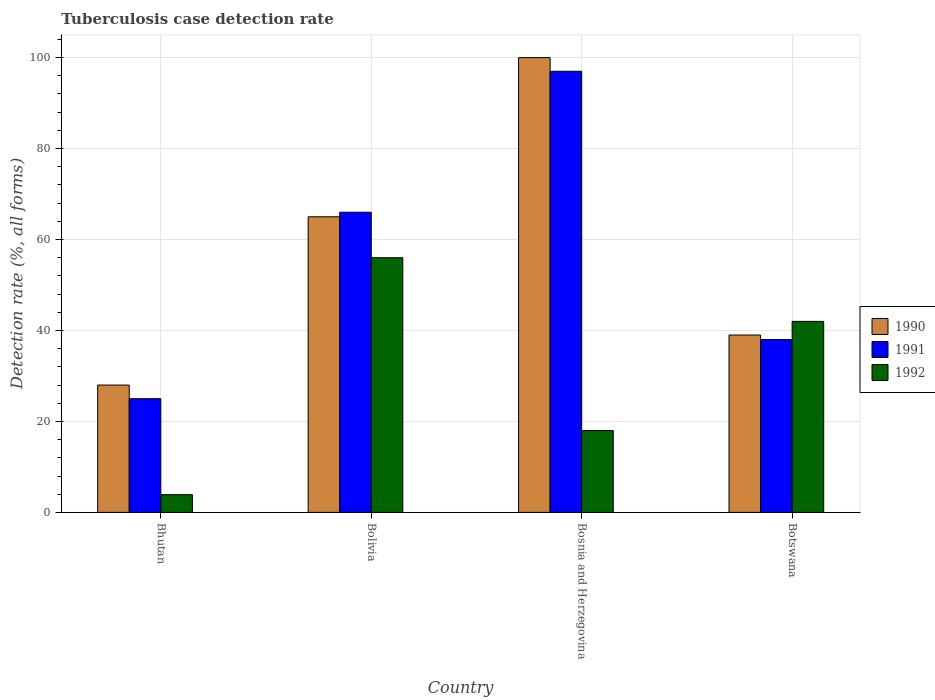How many groups of bars are there?
Give a very brief answer. 4. What is the label of the 3rd group of bars from the left?
Your answer should be compact. Bosnia and Herzegovina. What is the tuberculosis case detection rate in in 1992 in Bhutan?
Offer a very short reply. 3.9. Across all countries, what is the maximum tuberculosis case detection rate in in 1991?
Offer a terse response. 97. Across all countries, what is the minimum tuberculosis case detection rate in in 1990?
Your answer should be compact. 28. In which country was the tuberculosis case detection rate in in 1991 maximum?
Your answer should be very brief. Bosnia and Herzegovina. In which country was the tuberculosis case detection rate in in 1992 minimum?
Offer a terse response. Bhutan. What is the total tuberculosis case detection rate in in 1990 in the graph?
Make the answer very short. 232. What is the difference between the tuberculosis case detection rate in in 1992 in Bhutan and that in Bolivia?
Keep it short and to the point. -52.1. What is the average tuberculosis case detection rate in in 1991 per country?
Give a very brief answer. 56.5. In how many countries, is the tuberculosis case detection rate in in 1991 greater than 48 %?
Ensure brevity in your answer.  2. What is the ratio of the tuberculosis case detection rate in in 1992 in Bhutan to that in Bosnia and Herzegovina?
Give a very brief answer. 0.22. Is the difference between the tuberculosis case detection rate in in 1991 in Bolivia and Bosnia and Herzegovina greater than the difference between the tuberculosis case detection rate in in 1990 in Bolivia and Bosnia and Herzegovina?
Your answer should be very brief. Yes. What is the difference between the highest and the second highest tuberculosis case detection rate in in 1990?
Ensure brevity in your answer.  -35. What is the difference between the highest and the lowest tuberculosis case detection rate in in 1991?
Your response must be concise. 72. In how many countries, is the tuberculosis case detection rate in in 1992 greater than the average tuberculosis case detection rate in in 1992 taken over all countries?
Your answer should be very brief. 2. Is the sum of the tuberculosis case detection rate in in 1990 in Bolivia and Botswana greater than the maximum tuberculosis case detection rate in in 1991 across all countries?
Keep it short and to the point. Yes. What does the 2nd bar from the left in Botswana represents?
Your answer should be very brief. 1991. What does the 3rd bar from the right in Bhutan represents?
Provide a short and direct response. 1990. Is it the case that in every country, the sum of the tuberculosis case detection rate in in 1992 and tuberculosis case detection rate in in 1990 is greater than the tuberculosis case detection rate in in 1991?
Make the answer very short. Yes. Are all the bars in the graph horizontal?
Ensure brevity in your answer.  No. Where does the legend appear in the graph?
Provide a succinct answer. Center right. How are the legend labels stacked?
Your answer should be very brief. Vertical. What is the title of the graph?
Provide a succinct answer. Tuberculosis case detection rate. What is the label or title of the Y-axis?
Make the answer very short. Detection rate (%, all forms). What is the Detection rate (%, all forms) in 1990 in Bhutan?
Provide a succinct answer. 28. What is the Detection rate (%, all forms) in 1991 in Bhutan?
Offer a very short reply. 25. What is the Detection rate (%, all forms) in 1990 in Bolivia?
Your response must be concise. 65. What is the Detection rate (%, all forms) in 1991 in Bolivia?
Provide a short and direct response. 66. What is the Detection rate (%, all forms) of 1992 in Bolivia?
Provide a succinct answer. 56. What is the Detection rate (%, all forms) of 1991 in Bosnia and Herzegovina?
Keep it short and to the point. 97. What is the Detection rate (%, all forms) in 1992 in Bosnia and Herzegovina?
Ensure brevity in your answer.  18. Across all countries, what is the maximum Detection rate (%, all forms) in 1991?
Ensure brevity in your answer.  97. Across all countries, what is the maximum Detection rate (%, all forms) in 1992?
Give a very brief answer. 56. Across all countries, what is the minimum Detection rate (%, all forms) in 1991?
Make the answer very short. 25. Across all countries, what is the minimum Detection rate (%, all forms) in 1992?
Offer a terse response. 3.9. What is the total Detection rate (%, all forms) in 1990 in the graph?
Provide a short and direct response. 232. What is the total Detection rate (%, all forms) of 1991 in the graph?
Provide a succinct answer. 226. What is the total Detection rate (%, all forms) of 1992 in the graph?
Offer a very short reply. 119.9. What is the difference between the Detection rate (%, all forms) of 1990 in Bhutan and that in Bolivia?
Your answer should be compact. -37. What is the difference between the Detection rate (%, all forms) of 1991 in Bhutan and that in Bolivia?
Give a very brief answer. -41. What is the difference between the Detection rate (%, all forms) of 1992 in Bhutan and that in Bolivia?
Provide a short and direct response. -52.1. What is the difference between the Detection rate (%, all forms) of 1990 in Bhutan and that in Bosnia and Herzegovina?
Your response must be concise. -72. What is the difference between the Detection rate (%, all forms) of 1991 in Bhutan and that in Bosnia and Herzegovina?
Your response must be concise. -72. What is the difference between the Detection rate (%, all forms) in 1992 in Bhutan and that in Bosnia and Herzegovina?
Ensure brevity in your answer.  -14.1. What is the difference between the Detection rate (%, all forms) in 1990 in Bhutan and that in Botswana?
Your response must be concise. -11. What is the difference between the Detection rate (%, all forms) of 1992 in Bhutan and that in Botswana?
Give a very brief answer. -38.1. What is the difference between the Detection rate (%, all forms) of 1990 in Bolivia and that in Bosnia and Herzegovina?
Give a very brief answer. -35. What is the difference between the Detection rate (%, all forms) in 1991 in Bolivia and that in Bosnia and Herzegovina?
Give a very brief answer. -31. What is the difference between the Detection rate (%, all forms) of 1990 in Bosnia and Herzegovina and that in Botswana?
Your answer should be very brief. 61. What is the difference between the Detection rate (%, all forms) in 1991 in Bosnia and Herzegovina and that in Botswana?
Provide a short and direct response. 59. What is the difference between the Detection rate (%, all forms) of 1992 in Bosnia and Herzegovina and that in Botswana?
Your answer should be very brief. -24. What is the difference between the Detection rate (%, all forms) of 1990 in Bhutan and the Detection rate (%, all forms) of 1991 in Bolivia?
Give a very brief answer. -38. What is the difference between the Detection rate (%, all forms) in 1991 in Bhutan and the Detection rate (%, all forms) in 1992 in Bolivia?
Provide a short and direct response. -31. What is the difference between the Detection rate (%, all forms) of 1990 in Bhutan and the Detection rate (%, all forms) of 1991 in Bosnia and Herzegovina?
Your answer should be compact. -69. What is the difference between the Detection rate (%, all forms) of 1990 in Bhutan and the Detection rate (%, all forms) of 1992 in Bosnia and Herzegovina?
Provide a succinct answer. 10. What is the difference between the Detection rate (%, all forms) in 1990 in Bhutan and the Detection rate (%, all forms) in 1991 in Botswana?
Give a very brief answer. -10. What is the difference between the Detection rate (%, all forms) of 1990 in Bhutan and the Detection rate (%, all forms) of 1992 in Botswana?
Provide a short and direct response. -14. What is the difference between the Detection rate (%, all forms) in 1991 in Bhutan and the Detection rate (%, all forms) in 1992 in Botswana?
Keep it short and to the point. -17. What is the difference between the Detection rate (%, all forms) of 1990 in Bolivia and the Detection rate (%, all forms) of 1991 in Bosnia and Herzegovina?
Your response must be concise. -32. What is the difference between the Detection rate (%, all forms) in 1990 in Bolivia and the Detection rate (%, all forms) in 1991 in Botswana?
Give a very brief answer. 27. What is the difference between the Detection rate (%, all forms) in 1990 in Bolivia and the Detection rate (%, all forms) in 1992 in Botswana?
Keep it short and to the point. 23. What is the difference between the Detection rate (%, all forms) in 1991 in Bolivia and the Detection rate (%, all forms) in 1992 in Botswana?
Ensure brevity in your answer.  24. What is the difference between the Detection rate (%, all forms) of 1990 in Bosnia and Herzegovina and the Detection rate (%, all forms) of 1991 in Botswana?
Keep it short and to the point. 62. What is the difference between the Detection rate (%, all forms) in 1991 in Bosnia and Herzegovina and the Detection rate (%, all forms) in 1992 in Botswana?
Your response must be concise. 55. What is the average Detection rate (%, all forms) in 1990 per country?
Your answer should be compact. 58. What is the average Detection rate (%, all forms) of 1991 per country?
Provide a succinct answer. 56.5. What is the average Detection rate (%, all forms) of 1992 per country?
Provide a succinct answer. 29.98. What is the difference between the Detection rate (%, all forms) of 1990 and Detection rate (%, all forms) of 1991 in Bhutan?
Offer a very short reply. 3. What is the difference between the Detection rate (%, all forms) of 1990 and Detection rate (%, all forms) of 1992 in Bhutan?
Your answer should be compact. 24.1. What is the difference between the Detection rate (%, all forms) in 1991 and Detection rate (%, all forms) in 1992 in Bhutan?
Offer a very short reply. 21.1. What is the difference between the Detection rate (%, all forms) in 1990 and Detection rate (%, all forms) in 1992 in Bolivia?
Offer a terse response. 9. What is the difference between the Detection rate (%, all forms) in 1991 and Detection rate (%, all forms) in 1992 in Bolivia?
Keep it short and to the point. 10. What is the difference between the Detection rate (%, all forms) of 1990 and Detection rate (%, all forms) of 1991 in Bosnia and Herzegovina?
Keep it short and to the point. 3. What is the difference between the Detection rate (%, all forms) in 1991 and Detection rate (%, all forms) in 1992 in Bosnia and Herzegovina?
Ensure brevity in your answer.  79. What is the ratio of the Detection rate (%, all forms) of 1990 in Bhutan to that in Bolivia?
Give a very brief answer. 0.43. What is the ratio of the Detection rate (%, all forms) in 1991 in Bhutan to that in Bolivia?
Keep it short and to the point. 0.38. What is the ratio of the Detection rate (%, all forms) of 1992 in Bhutan to that in Bolivia?
Keep it short and to the point. 0.07. What is the ratio of the Detection rate (%, all forms) of 1990 in Bhutan to that in Bosnia and Herzegovina?
Provide a short and direct response. 0.28. What is the ratio of the Detection rate (%, all forms) of 1991 in Bhutan to that in Bosnia and Herzegovina?
Make the answer very short. 0.26. What is the ratio of the Detection rate (%, all forms) in 1992 in Bhutan to that in Bosnia and Herzegovina?
Make the answer very short. 0.22. What is the ratio of the Detection rate (%, all forms) of 1990 in Bhutan to that in Botswana?
Offer a very short reply. 0.72. What is the ratio of the Detection rate (%, all forms) of 1991 in Bhutan to that in Botswana?
Give a very brief answer. 0.66. What is the ratio of the Detection rate (%, all forms) in 1992 in Bhutan to that in Botswana?
Ensure brevity in your answer.  0.09. What is the ratio of the Detection rate (%, all forms) in 1990 in Bolivia to that in Bosnia and Herzegovina?
Provide a short and direct response. 0.65. What is the ratio of the Detection rate (%, all forms) of 1991 in Bolivia to that in Bosnia and Herzegovina?
Offer a very short reply. 0.68. What is the ratio of the Detection rate (%, all forms) of 1992 in Bolivia to that in Bosnia and Herzegovina?
Provide a short and direct response. 3.11. What is the ratio of the Detection rate (%, all forms) of 1991 in Bolivia to that in Botswana?
Your answer should be compact. 1.74. What is the ratio of the Detection rate (%, all forms) of 1990 in Bosnia and Herzegovina to that in Botswana?
Provide a short and direct response. 2.56. What is the ratio of the Detection rate (%, all forms) in 1991 in Bosnia and Herzegovina to that in Botswana?
Offer a terse response. 2.55. What is the ratio of the Detection rate (%, all forms) in 1992 in Bosnia and Herzegovina to that in Botswana?
Offer a terse response. 0.43. What is the difference between the highest and the second highest Detection rate (%, all forms) in 1991?
Provide a succinct answer. 31. What is the difference between the highest and the second highest Detection rate (%, all forms) of 1992?
Your answer should be very brief. 14. What is the difference between the highest and the lowest Detection rate (%, all forms) of 1990?
Keep it short and to the point. 72. What is the difference between the highest and the lowest Detection rate (%, all forms) in 1992?
Your answer should be very brief. 52.1. 